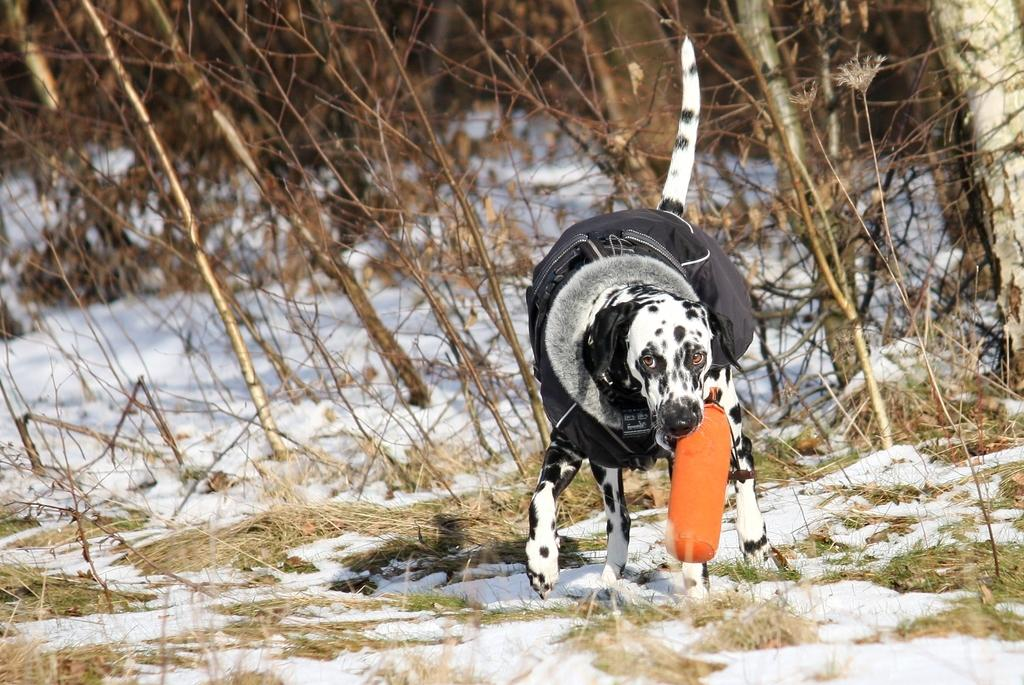What type of animal is present in the image? There is a dog in the image. What is the dog doing in the image? The dog is holding an object in its mouth. What is the environment like in the image? There is snow and grass visible in the image, and there are also plants present. What type of mint is being taught to the dog in the image? There is no mint or teaching activity present in the image; it features a dog holding an object in its mouth in a snowy environment with grass and plants. 